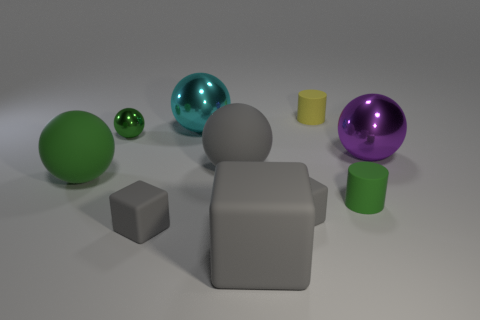What number of rubber objects are either large red cylinders or big things?
Your response must be concise. 3. Does the object that is left of the small green metal thing have the same color as the matte cylinder that is in front of the large green matte sphere?
Make the answer very short. Yes. There is a cyan object that is the same shape as the large green rubber object; what size is it?
Make the answer very short. Large. Are there more things that are on the left side of the yellow cylinder than tiny blue cubes?
Ensure brevity in your answer.  Yes. Does the green ball that is in front of the gray sphere have the same material as the gray sphere?
Your answer should be compact. Yes. What is the size of the gray matte object that is on the right side of the large gray thing in front of the small green cylinder that is in front of the big cyan metallic ball?
Provide a succinct answer. Small. There is a green ball that is the same material as the cyan ball; what size is it?
Provide a succinct answer. Small. There is a small object that is on the left side of the cyan metallic sphere and in front of the big green ball; what is its color?
Ensure brevity in your answer.  Gray. There is a gray rubber object behind the small green rubber thing; does it have the same shape as the tiny gray object that is on the right side of the cyan ball?
Offer a very short reply. No. What is the material of the green thing that is behind the purple shiny sphere?
Your answer should be compact. Metal. 